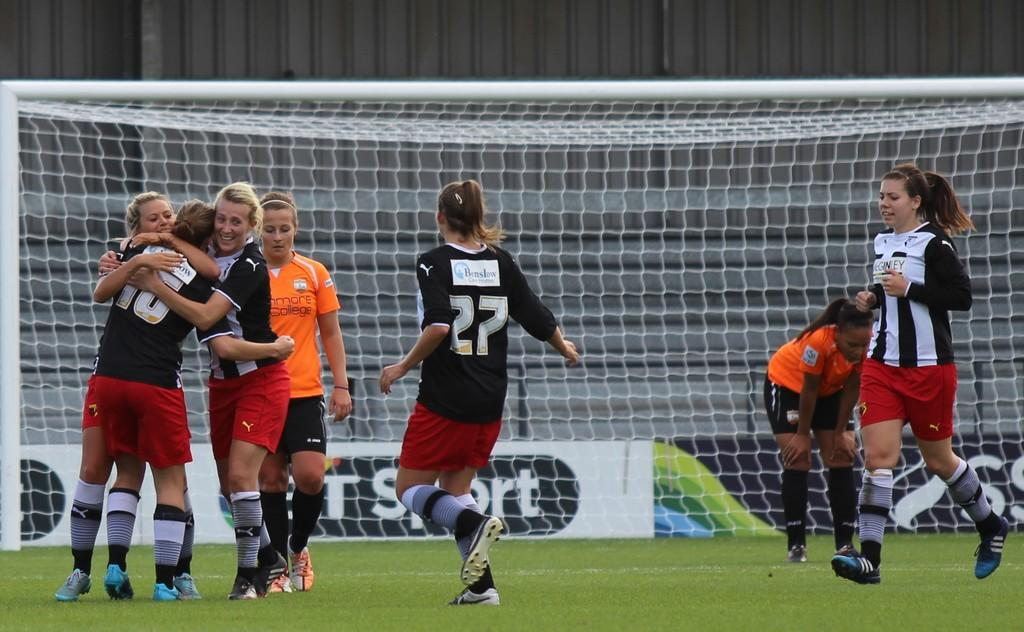<image>
Create a compact narrative representing the image presented. Players embrace number 15 on a soccer team, who seems to have just scored a goal. 